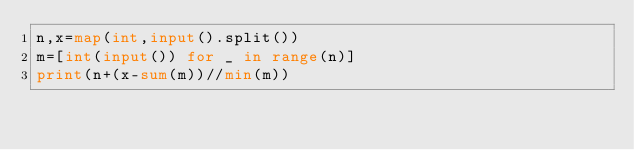Convert code to text. <code><loc_0><loc_0><loc_500><loc_500><_Python_>n,x=map(int,input().split())
m=[int(input()) for _ in range(n)]
print(n+(x-sum(m))//min(m))</code> 